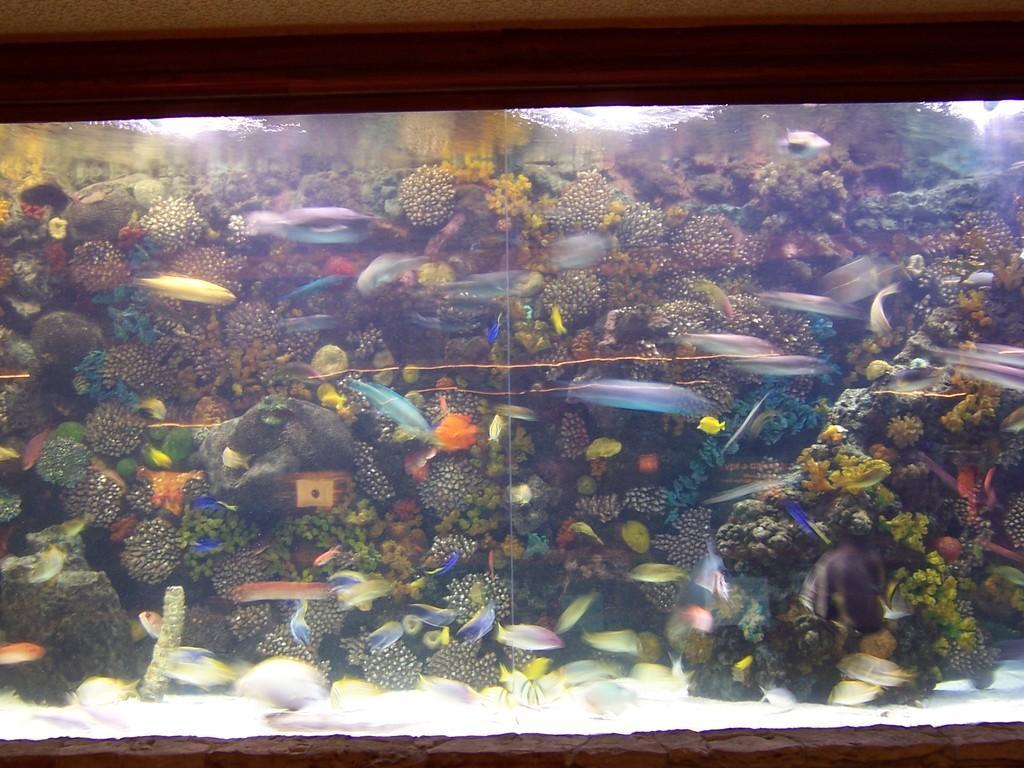How would you summarize this image in a sentence or two? There is an aquarium in which, there are fishes, plants and water. And the background is dark in color. 